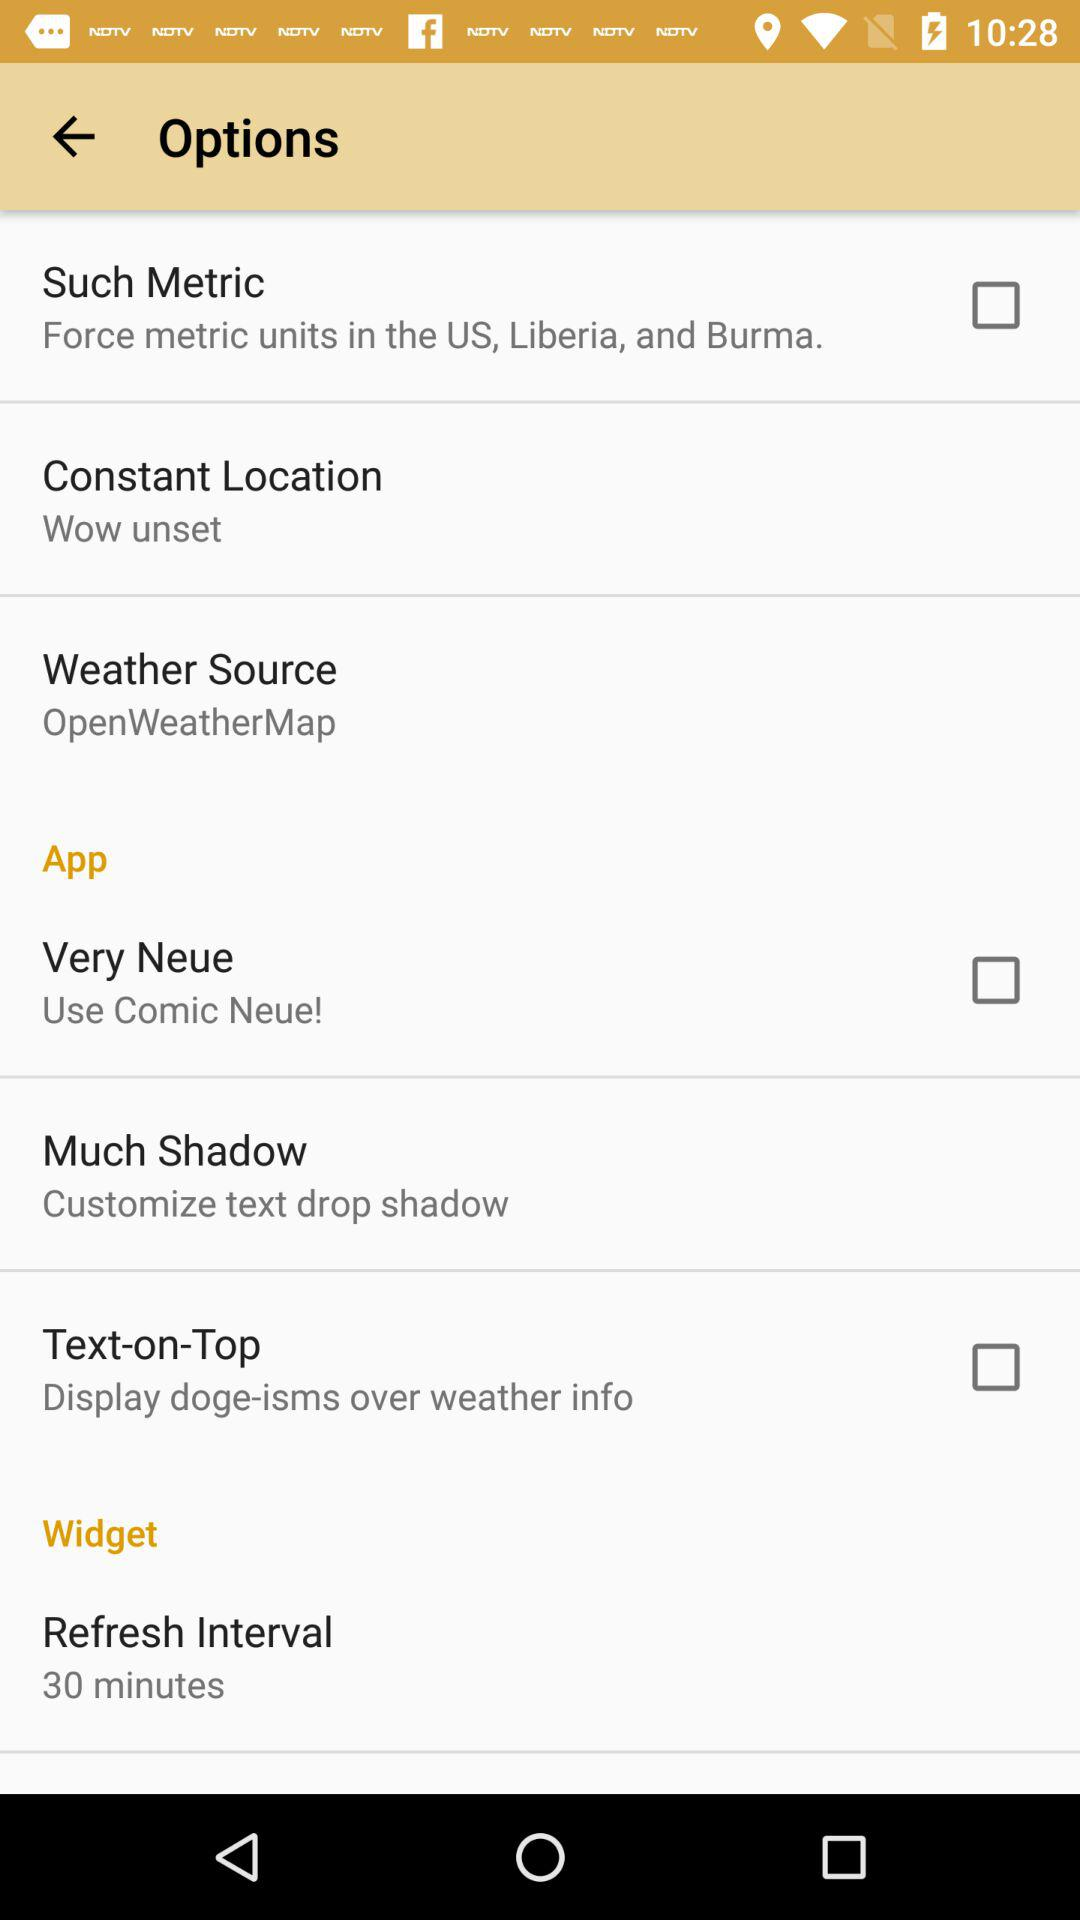What are the options available? The available options are "Such Metric", "Constant Location", and "Weather Source". 